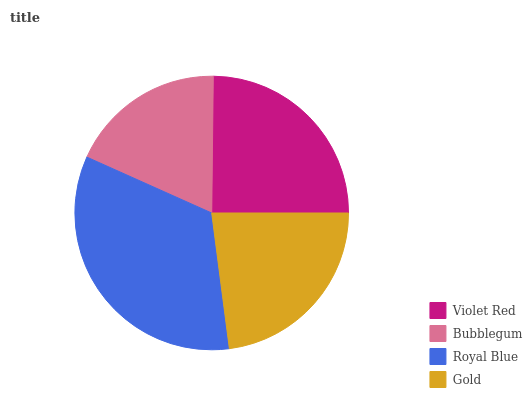Is Bubblegum the minimum?
Answer yes or no. Yes. Is Royal Blue the maximum?
Answer yes or no. Yes. Is Royal Blue the minimum?
Answer yes or no. No. Is Bubblegum the maximum?
Answer yes or no. No. Is Royal Blue greater than Bubblegum?
Answer yes or no. Yes. Is Bubblegum less than Royal Blue?
Answer yes or no. Yes. Is Bubblegum greater than Royal Blue?
Answer yes or no. No. Is Royal Blue less than Bubblegum?
Answer yes or no. No. Is Violet Red the high median?
Answer yes or no. Yes. Is Gold the low median?
Answer yes or no. Yes. Is Bubblegum the high median?
Answer yes or no. No. Is Violet Red the low median?
Answer yes or no. No. 